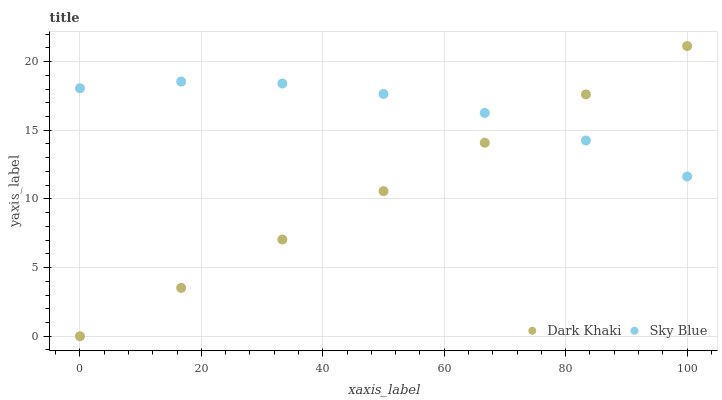Does Dark Khaki have the minimum area under the curve?
Answer yes or no. Yes. Does Sky Blue have the maximum area under the curve?
Answer yes or no. Yes. Does Sky Blue have the minimum area under the curve?
Answer yes or no. No. Is Dark Khaki the smoothest?
Answer yes or no. Yes. Is Sky Blue the roughest?
Answer yes or no. Yes. Is Sky Blue the smoothest?
Answer yes or no. No. Does Dark Khaki have the lowest value?
Answer yes or no. Yes. Does Sky Blue have the lowest value?
Answer yes or no. No. Does Dark Khaki have the highest value?
Answer yes or no. Yes. Does Sky Blue have the highest value?
Answer yes or no. No. Does Dark Khaki intersect Sky Blue?
Answer yes or no. Yes. Is Dark Khaki less than Sky Blue?
Answer yes or no. No. Is Dark Khaki greater than Sky Blue?
Answer yes or no. No. 